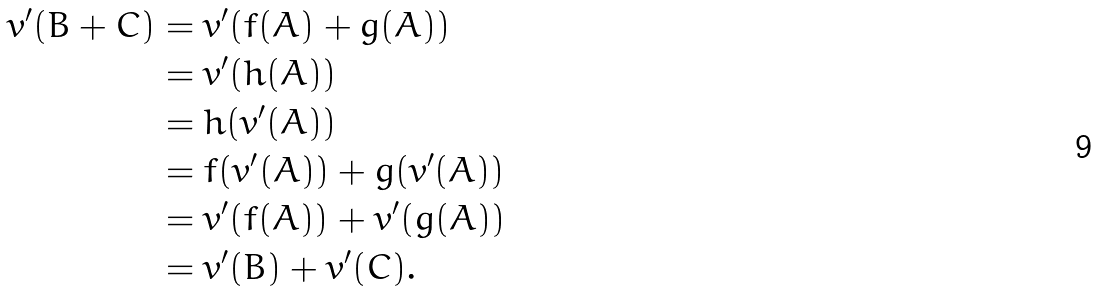<formula> <loc_0><loc_0><loc_500><loc_500>v ^ { \prime } ( B + C ) & = v ^ { \prime } ( f ( A ) + g ( A ) ) \\ & = v ^ { \prime } ( h ( A ) ) \\ & = h ( v ^ { \prime } ( A ) ) \\ & = f ( v ^ { \prime } ( A ) ) + g ( v ^ { \prime } ( A ) ) \\ & = v ^ { \prime } ( f ( A ) ) + v ^ { \prime } ( g ( A ) ) \\ & = v ^ { \prime } ( B ) + v ^ { \prime } ( C ) .</formula> 